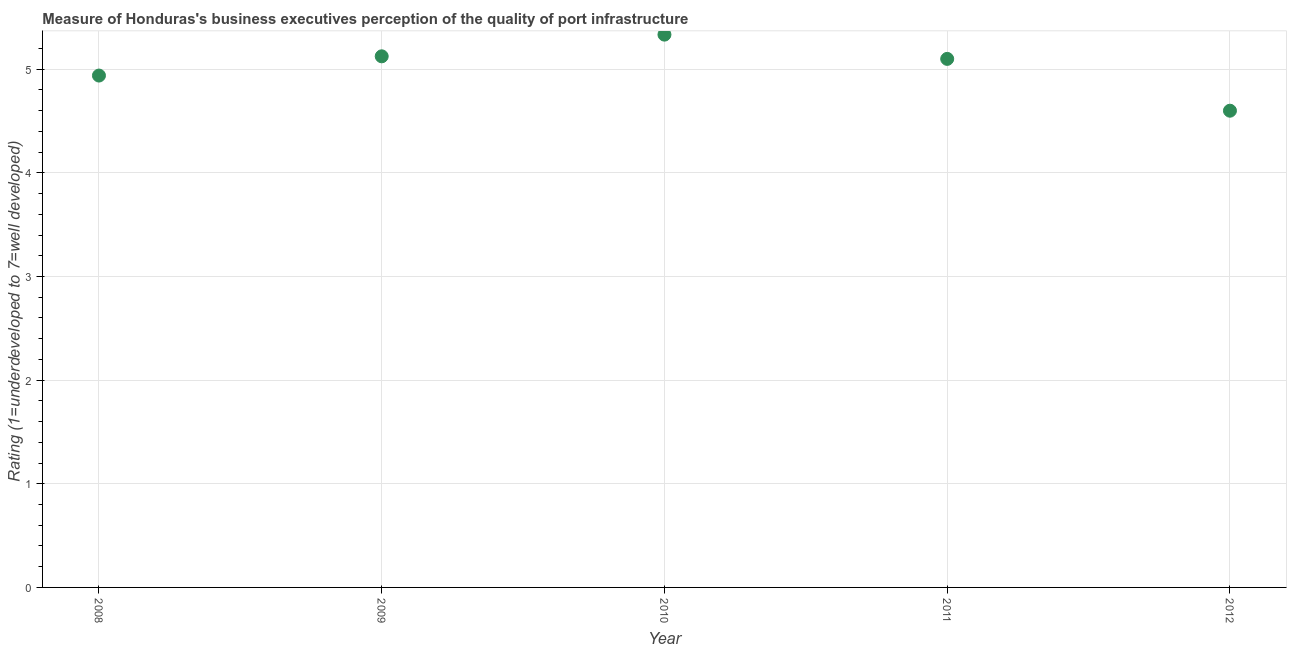What is the rating measuring quality of port infrastructure in 2012?
Ensure brevity in your answer.  4.6. Across all years, what is the maximum rating measuring quality of port infrastructure?
Offer a very short reply. 5.33. Across all years, what is the minimum rating measuring quality of port infrastructure?
Offer a terse response. 4.6. In which year was the rating measuring quality of port infrastructure maximum?
Make the answer very short. 2010. What is the sum of the rating measuring quality of port infrastructure?
Ensure brevity in your answer.  25.1. What is the difference between the rating measuring quality of port infrastructure in 2010 and 2012?
Provide a succinct answer. 0.73. What is the average rating measuring quality of port infrastructure per year?
Your response must be concise. 5.02. In how many years, is the rating measuring quality of port infrastructure greater than 0.6000000000000001 ?
Keep it short and to the point. 5. Do a majority of the years between 2012 and 2008 (inclusive) have rating measuring quality of port infrastructure greater than 1.8 ?
Provide a succinct answer. Yes. What is the ratio of the rating measuring quality of port infrastructure in 2009 to that in 2012?
Your response must be concise. 1.11. Is the rating measuring quality of port infrastructure in 2011 less than that in 2012?
Your response must be concise. No. Is the difference between the rating measuring quality of port infrastructure in 2009 and 2010 greater than the difference between any two years?
Keep it short and to the point. No. What is the difference between the highest and the second highest rating measuring quality of port infrastructure?
Your answer should be very brief. 0.21. What is the difference between the highest and the lowest rating measuring quality of port infrastructure?
Make the answer very short. 0.73. How many years are there in the graph?
Offer a very short reply. 5. Does the graph contain any zero values?
Your answer should be compact. No. What is the title of the graph?
Offer a terse response. Measure of Honduras's business executives perception of the quality of port infrastructure. What is the label or title of the Y-axis?
Give a very brief answer. Rating (1=underdeveloped to 7=well developed) . What is the Rating (1=underdeveloped to 7=well developed)  in 2008?
Make the answer very short. 4.94. What is the Rating (1=underdeveloped to 7=well developed)  in 2009?
Make the answer very short. 5.12. What is the Rating (1=underdeveloped to 7=well developed)  in 2010?
Provide a succinct answer. 5.33. What is the difference between the Rating (1=underdeveloped to 7=well developed)  in 2008 and 2009?
Give a very brief answer. -0.19. What is the difference between the Rating (1=underdeveloped to 7=well developed)  in 2008 and 2010?
Offer a very short reply. -0.39. What is the difference between the Rating (1=underdeveloped to 7=well developed)  in 2008 and 2011?
Your answer should be very brief. -0.16. What is the difference between the Rating (1=underdeveloped to 7=well developed)  in 2008 and 2012?
Your answer should be compact. 0.34. What is the difference between the Rating (1=underdeveloped to 7=well developed)  in 2009 and 2010?
Offer a terse response. -0.21. What is the difference between the Rating (1=underdeveloped to 7=well developed)  in 2009 and 2011?
Give a very brief answer. 0.02. What is the difference between the Rating (1=underdeveloped to 7=well developed)  in 2009 and 2012?
Your answer should be very brief. 0.52. What is the difference between the Rating (1=underdeveloped to 7=well developed)  in 2010 and 2011?
Offer a very short reply. 0.23. What is the difference between the Rating (1=underdeveloped to 7=well developed)  in 2010 and 2012?
Your response must be concise. 0.73. What is the difference between the Rating (1=underdeveloped to 7=well developed)  in 2011 and 2012?
Your answer should be compact. 0.5. What is the ratio of the Rating (1=underdeveloped to 7=well developed)  in 2008 to that in 2009?
Offer a very short reply. 0.96. What is the ratio of the Rating (1=underdeveloped to 7=well developed)  in 2008 to that in 2010?
Give a very brief answer. 0.93. What is the ratio of the Rating (1=underdeveloped to 7=well developed)  in 2008 to that in 2012?
Keep it short and to the point. 1.07. What is the ratio of the Rating (1=underdeveloped to 7=well developed)  in 2009 to that in 2011?
Offer a terse response. 1. What is the ratio of the Rating (1=underdeveloped to 7=well developed)  in 2009 to that in 2012?
Keep it short and to the point. 1.11. What is the ratio of the Rating (1=underdeveloped to 7=well developed)  in 2010 to that in 2011?
Ensure brevity in your answer.  1.05. What is the ratio of the Rating (1=underdeveloped to 7=well developed)  in 2010 to that in 2012?
Make the answer very short. 1.16. What is the ratio of the Rating (1=underdeveloped to 7=well developed)  in 2011 to that in 2012?
Provide a short and direct response. 1.11. 